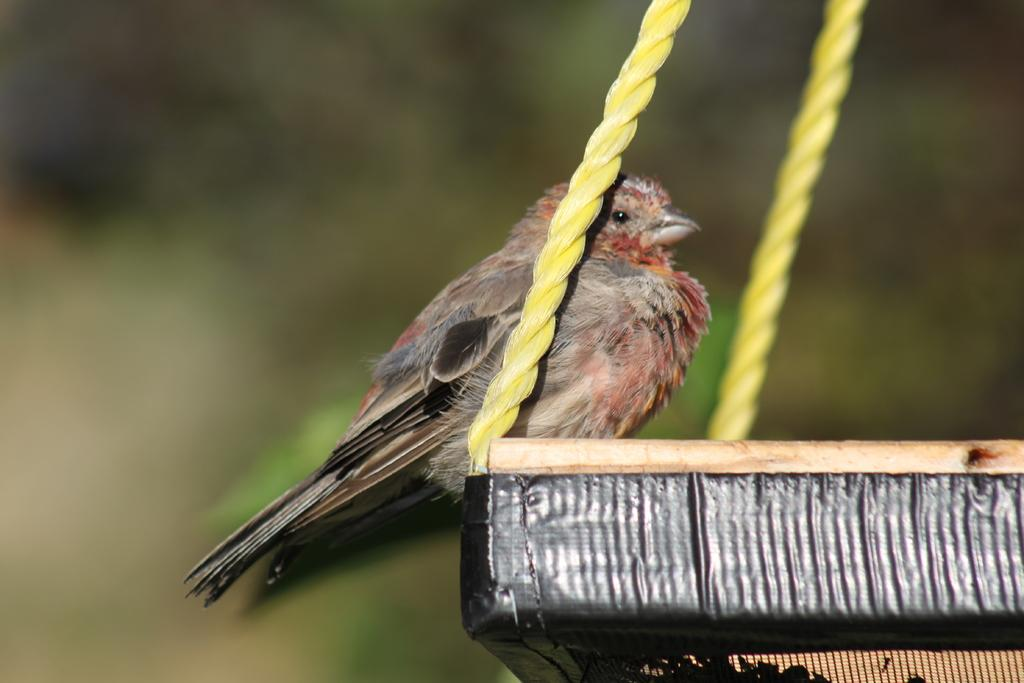What type of animal is present in the image? There is a bird in the image. Where is the bird located? The bird is on an object in the image. What other items can be seen in the image? There are ropes in the image. Can you describe the background of the image? The background of the image is blurry. What type of hole can be seen on the island in the image? There is no island or hole present in the image; it features a bird on an object with ropes in the background. 